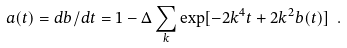Convert formula to latex. <formula><loc_0><loc_0><loc_500><loc_500>a ( t ) = d b / d t = 1 - \Delta \sum _ { k } \exp [ - 2 k ^ { 4 } t + 2 k ^ { 2 } b ( t ) ] \ .</formula> 